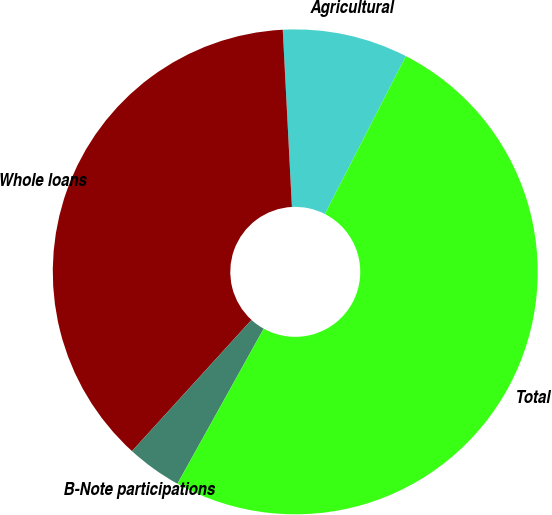<chart> <loc_0><loc_0><loc_500><loc_500><pie_chart><fcel>Agricultural<fcel>Whole loans<fcel>B-Note participations<fcel>Total<nl><fcel>8.36%<fcel>37.42%<fcel>3.68%<fcel>50.54%<nl></chart> 